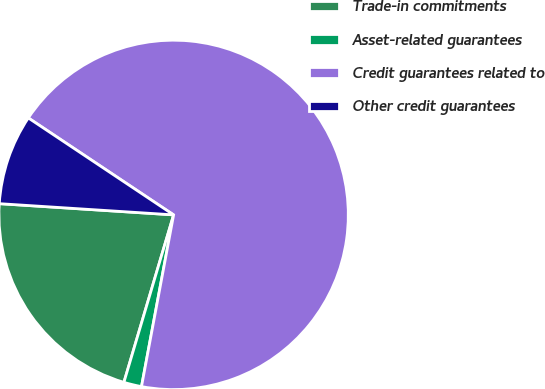Convert chart to OTSL. <chart><loc_0><loc_0><loc_500><loc_500><pie_chart><fcel>Trade-in commitments<fcel>Asset-related guarantees<fcel>Credit guarantees related to<fcel>Other credit guarantees<nl><fcel>21.43%<fcel>1.65%<fcel>68.58%<fcel>8.34%<nl></chart> 